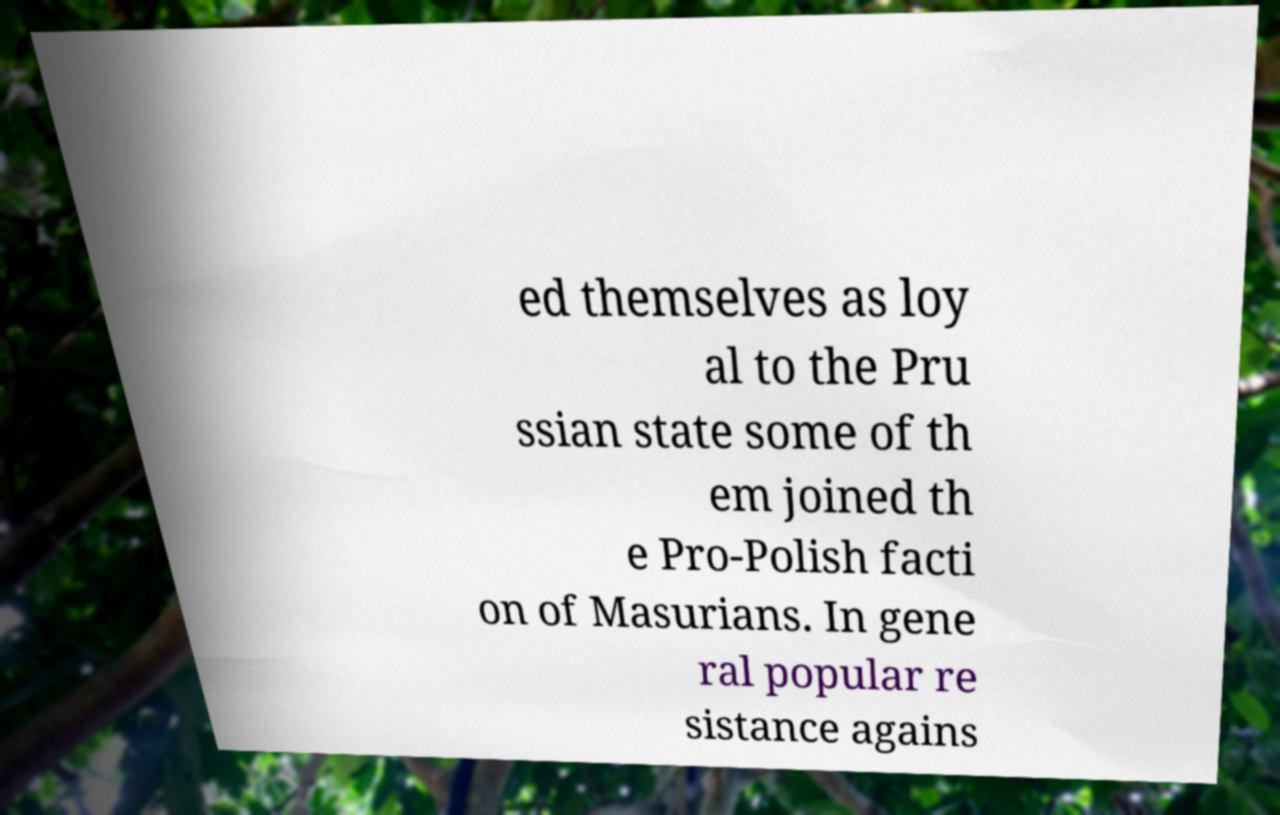Could you extract and type out the text from this image? ed themselves as loy al to the Pru ssian state some of th em joined th e Pro-Polish facti on of Masurians. In gene ral popular re sistance agains 